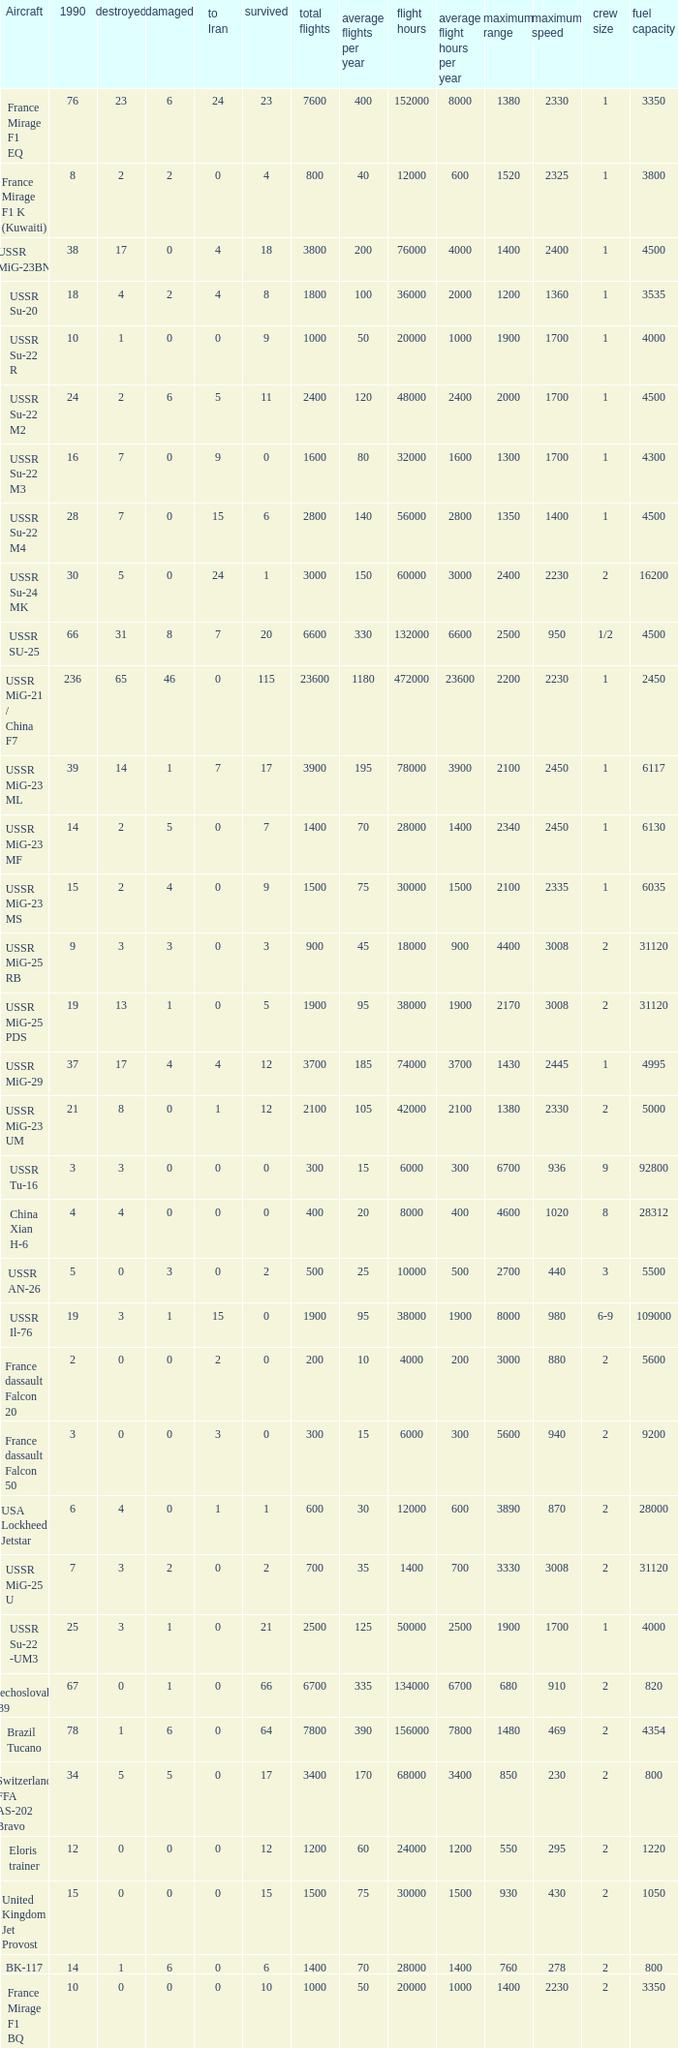If 4 went to iran and the amount that survived was less than 12.0 how many were there in 1990? 1.0. 